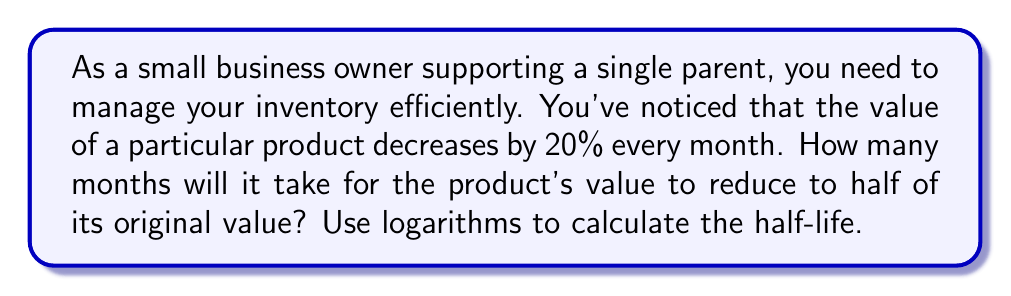Solve this math problem. Let's approach this step-by-step using logarithms:

1) Let $t$ be the number of months it takes for the value to halve.

2) After $t$ months, the remaining value will be $(0.8)^t$ of the original value, where 0.8 represents 80% (100% - 20% decrease).

3) We can express this as an equation:

   $$(0.8)^t = 0.5$$

4) To solve for $t$, we need to use logarithms. Let's apply the natural log (ln) to both sides:

   $$\ln((0.8)^t) = \ln(0.5)$$

5) Using the logarithm property $\ln(a^b) = b\ln(a)$, we get:

   $$t \cdot \ln(0.8) = \ln(0.5)$$

6) Now we can solve for $t$:

   $$t = \frac{\ln(0.5)}{\ln(0.8)}$$

7) Using a calculator or computer:

   $$t \approx 3.1067$$

8) Since we can't have a fractional month in this context, we round up to the nearest whole month.

Therefore, it will take 4 months for the product's value to reduce to half of its original value.
Answer: 4 months 